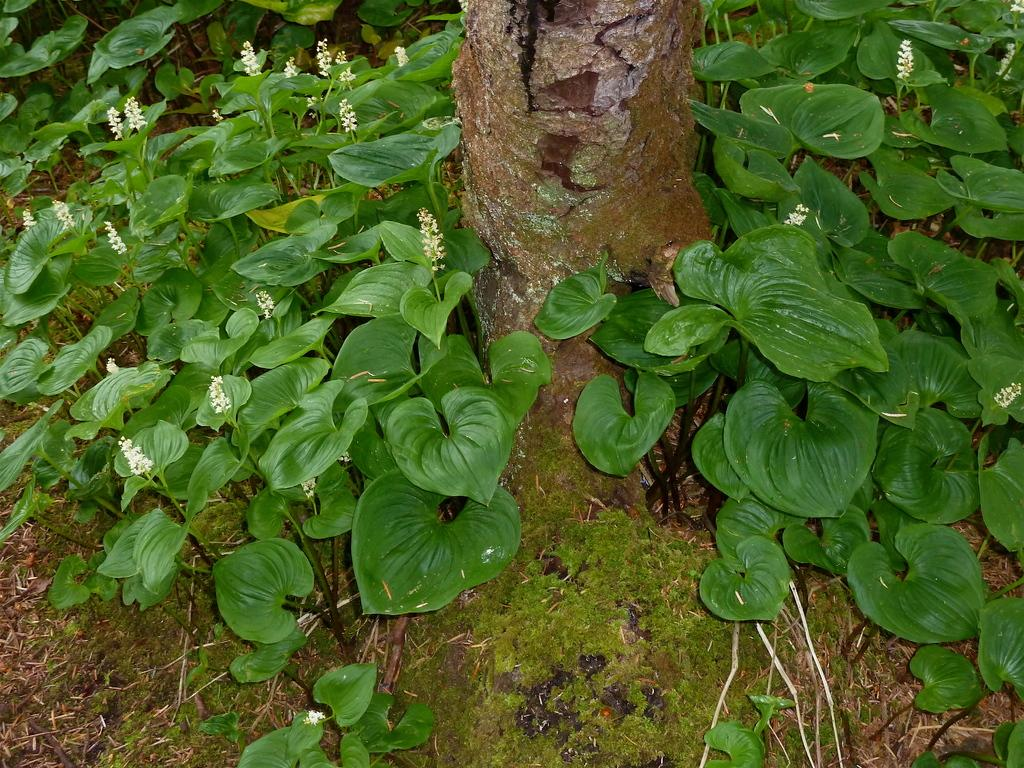What type of plants can be seen in the image? There are plants with small flowers in the image. What is covering the ground in the image? There is grass on the ground in the image. What part of a tree is visible in the image? There is a tree trunk in the image. What type of hook can be seen hanging from the tree trunk in the image? There is no hook present in the image; only plants, grass, and a tree trunk are visible. 